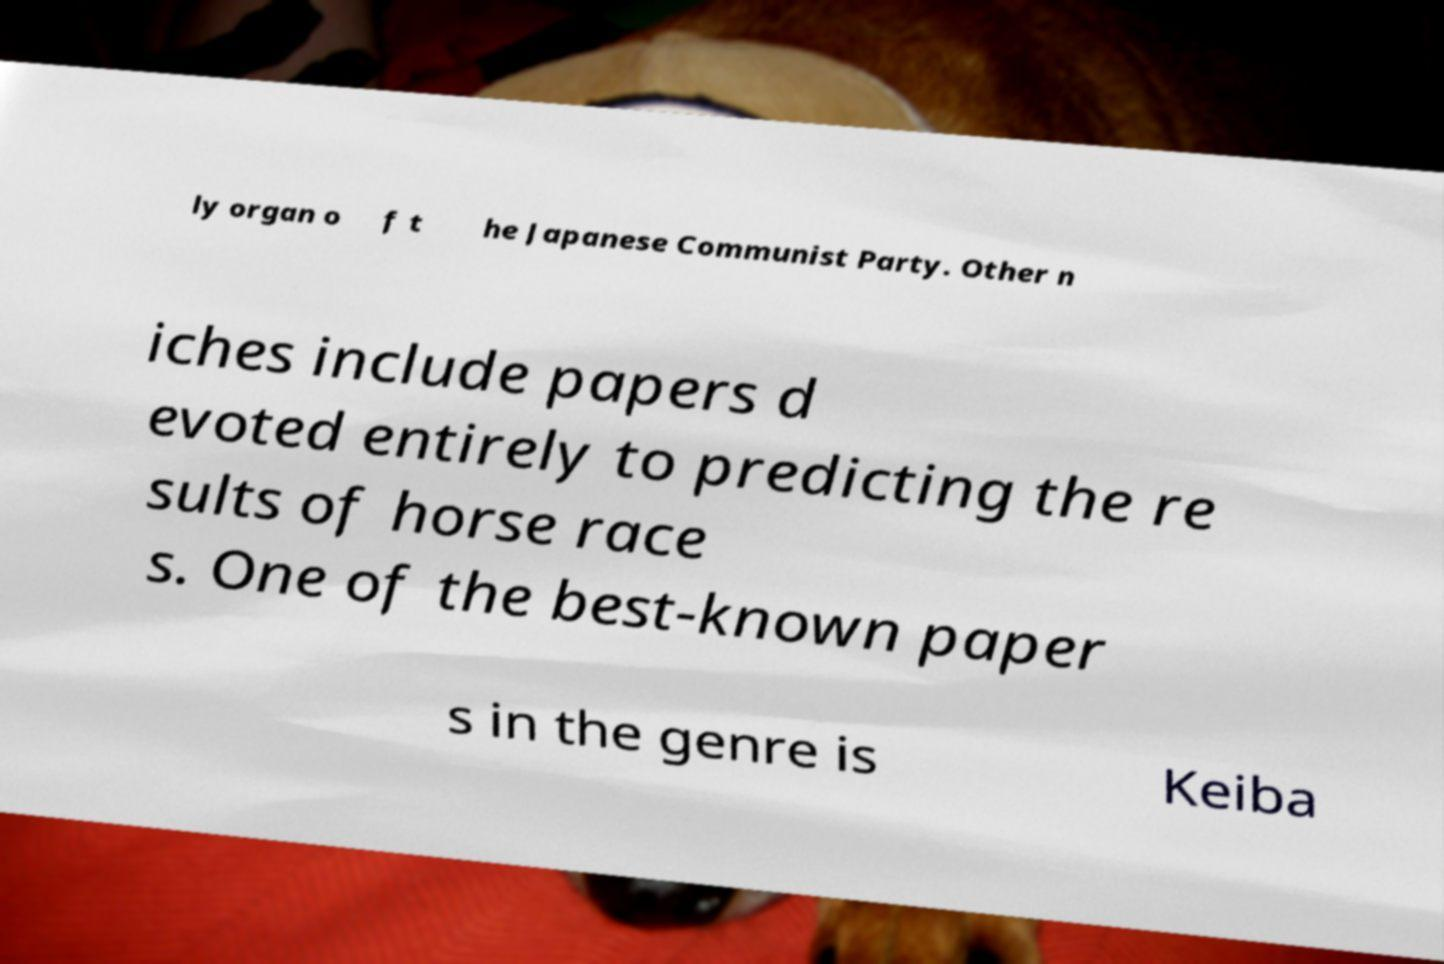Please identify and transcribe the text found in this image. ly organ o f t he Japanese Communist Party. Other n iches include papers d evoted entirely to predicting the re sults of horse race s. One of the best-known paper s in the genre is Keiba 